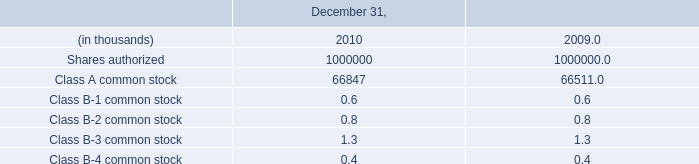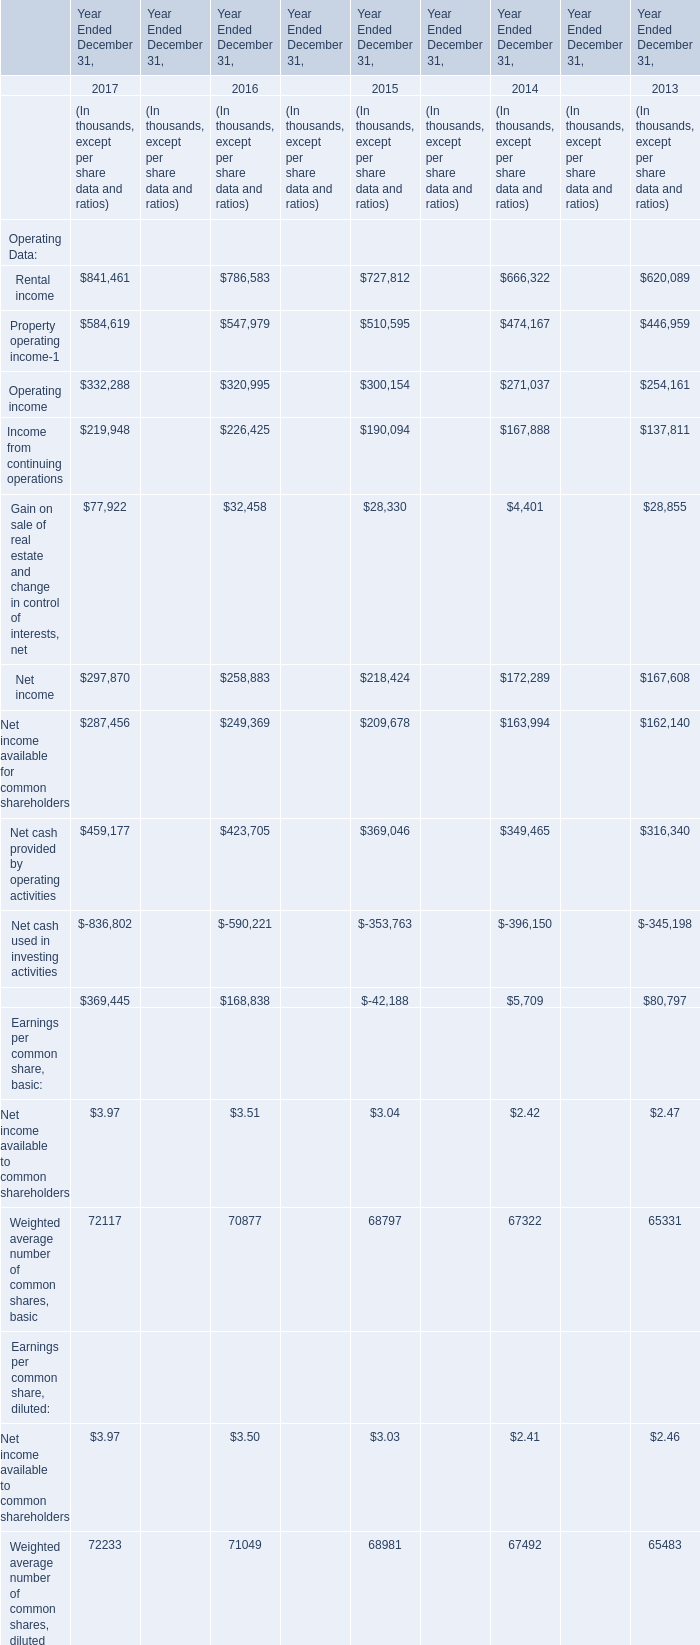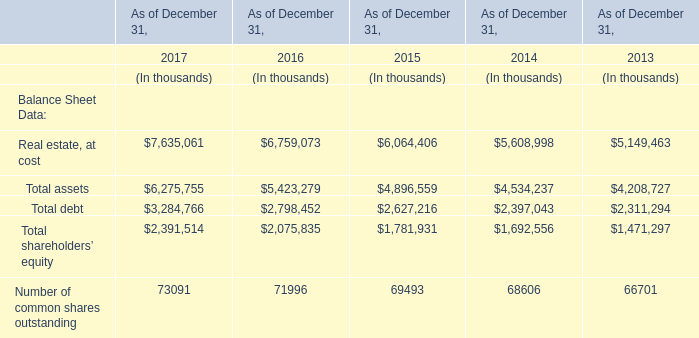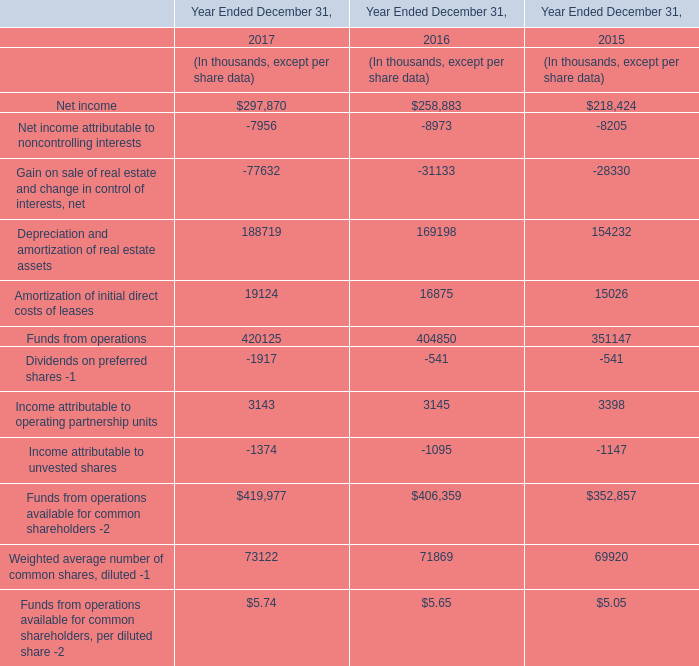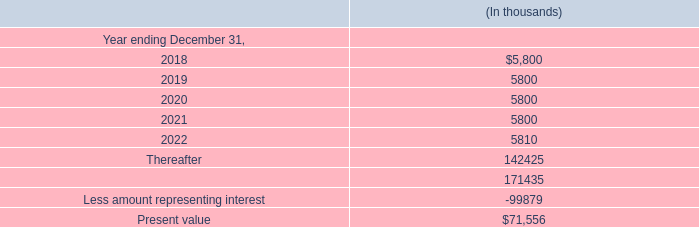What was the average of Total debt in 2016, 2015, and 2014 ? (in thousand) 
Computations: (((2798452 + 2627216) + 2397043) / 3)
Answer: 2607570.33333. 